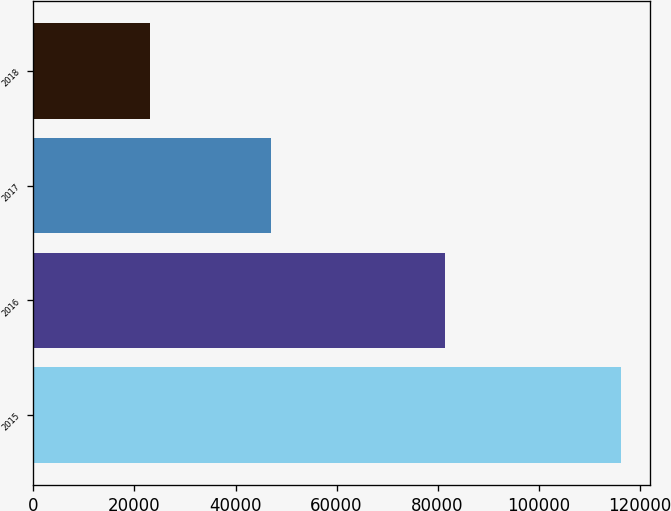<chart> <loc_0><loc_0><loc_500><loc_500><bar_chart><fcel>2015<fcel>2016<fcel>2017<fcel>2018<nl><fcel>116324<fcel>81419<fcel>47039<fcel>23113<nl></chart> 